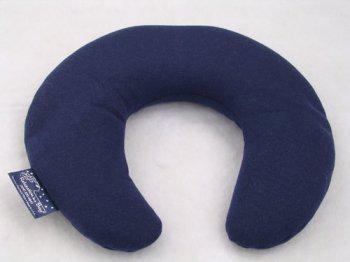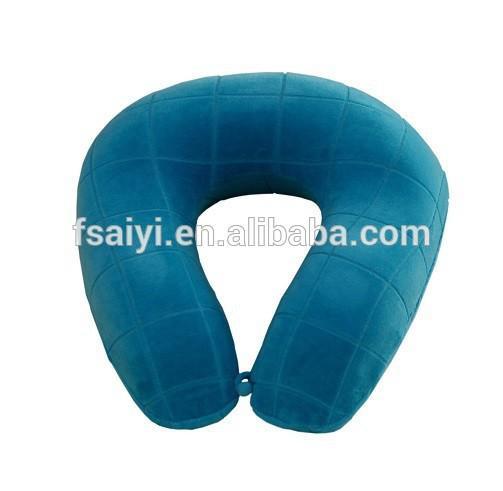The first image is the image on the left, the second image is the image on the right. Examine the images to the left and right. Is the description "The left image contains one oblong blue pillow, and the right image includes a bright blue horseshoe-shaped pillow." accurate? Answer yes or no. No. The first image is the image on the left, the second image is the image on the right. For the images shown, is this caption "The left image has a neck pillow in a cylindrical shape." true? Answer yes or no. No. 